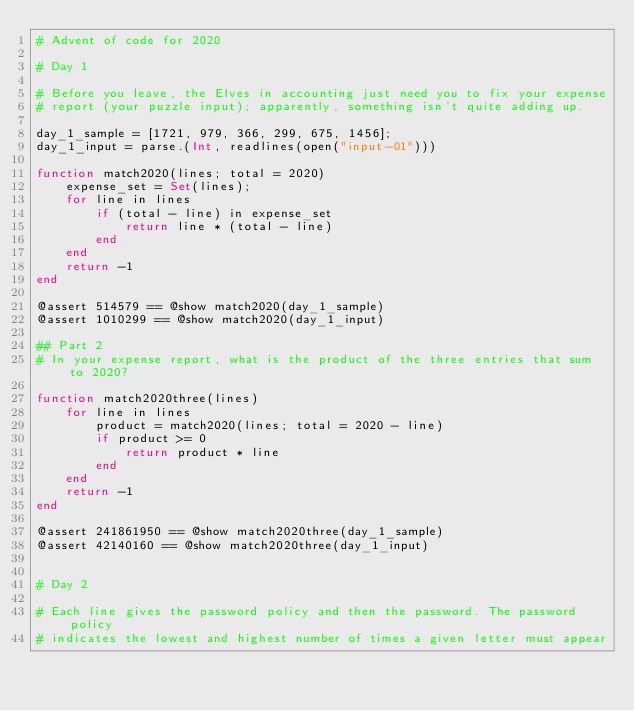<code> <loc_0><loc_0><loc_500><loc_500><_Julia_># Advent of code for 2020

# Day 1

# Before you leave, the Elves in accounting just need you to fix your expense
# report (your puzzle input); apparently, something isn't quite adding up.

day_1_sample = [1721, 979, 366, 299, 675, 1456];
day_1_input = parse.(Int, readlines(open("input-01")))

function match2020(lines; total = 2020)
    expense_set = Set(lines);
    for line in lines
        if (total - line) in expense_set
            return line * (total - line)
        end
    end
    return -1
end

@assert 514579 == @show match2020(day_1_sample)
@assert 1010299 == @show match2020(day_1_input)

## Part 2
# In your expense report, what is the product of the three entries that sum to 2020?

function match2020three(lines)
    for line in lines
        product = match2020(lines; total = 2020 - line)
        if product >= 0
            return product * line
        end
    end
    return -1
end

@assert 241861950 == @show match2020three(day_1_sample)
@assert 42140160 == @show match2020three(day_1_input)


# Day 2

# Each line gives the password policy and then the password. The password policy
# indicates the lowest and highest number of times a given letter must appear</code> 